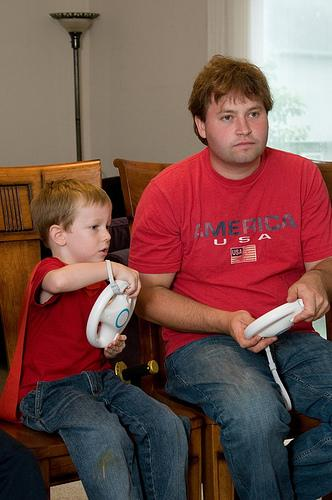Question: why are people holding game controllers?
Choices:
A. To play a video game.
B. So they can steal them.
C. To hit each other with.
D. To demonstrate how they work.
Answer with the letter. Answer: A Question: what is red?
Choices:
A. Birds.
B. Man's shirt.
C. Parachutes.
D. Balloons.
Answer with the letter. Answer: B Question: who has on blue jeans?
Choices:
A. The gigantic woman with moles on her nose.
B. Two people.
C. A scary clown.
D. The captain of the ship.
Answer with the letter. Answer: B Question: what is is brown and wooden?
Choices:
A. Popsicle sticks.
B. Trees.
C. Pencils.
D. Chairs.
Answer with the letter. Answer: D Question: where was the photo taken?
Choices:
A. Front yard.
B. Back yard.
C. Swimming pool.
D. Inside of house.
Answer with the letter. Answer: D 